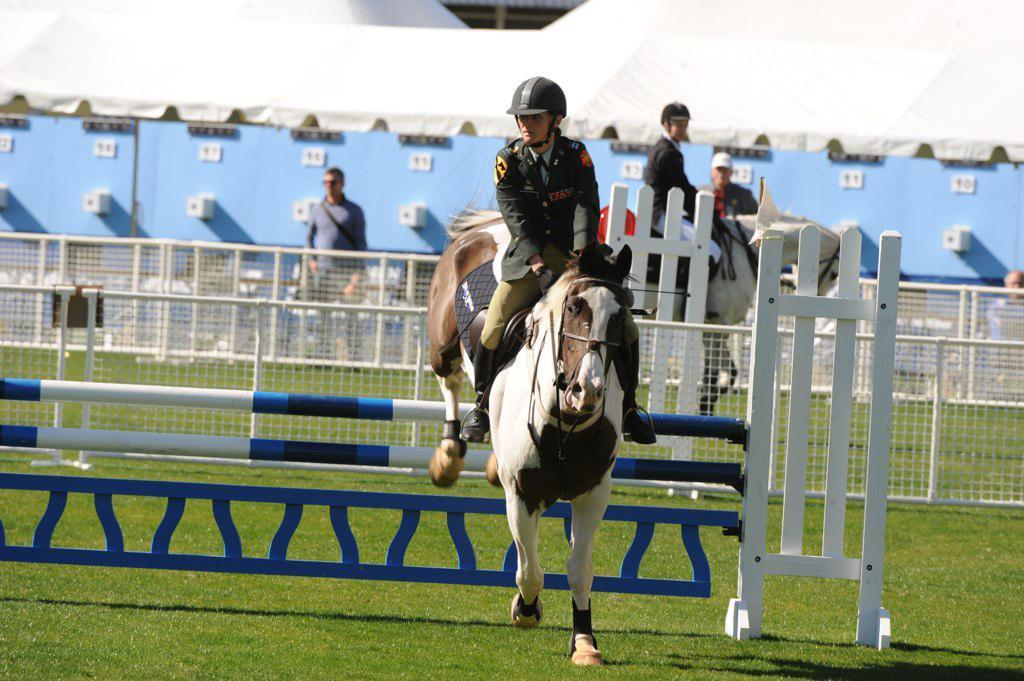How would you summarize this image in a sentence or two? In this image there are people, horses, railings, tent, rods and object. Land is covered with grass.   